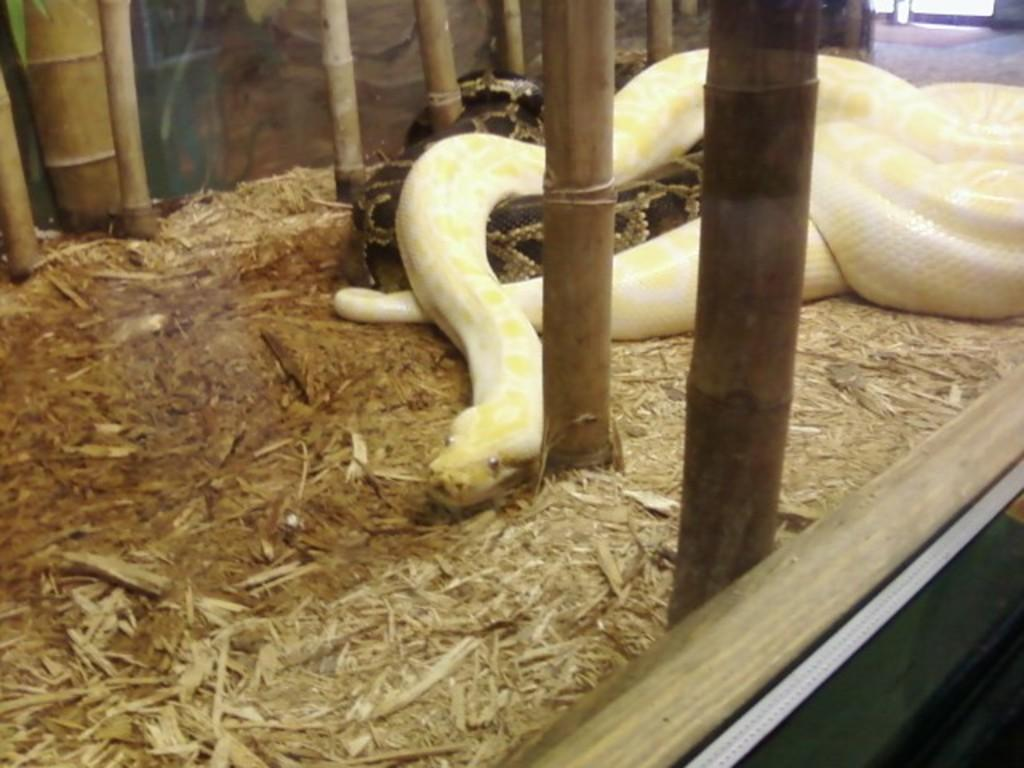What animals can be seen in the image? There are snakes on wooden pieces in the image. What objects are around the snakes? There are sticks around the snakes in the image. What type of container or structure is visible in the image? The image appears to show a box or container. Can you describe the setting of the image? The setting seems to be indoors, possibly inside a building. How many oranges are being digested by the snakes in the image? There are no oranges present in the image, and snakes do not digest oranges. 